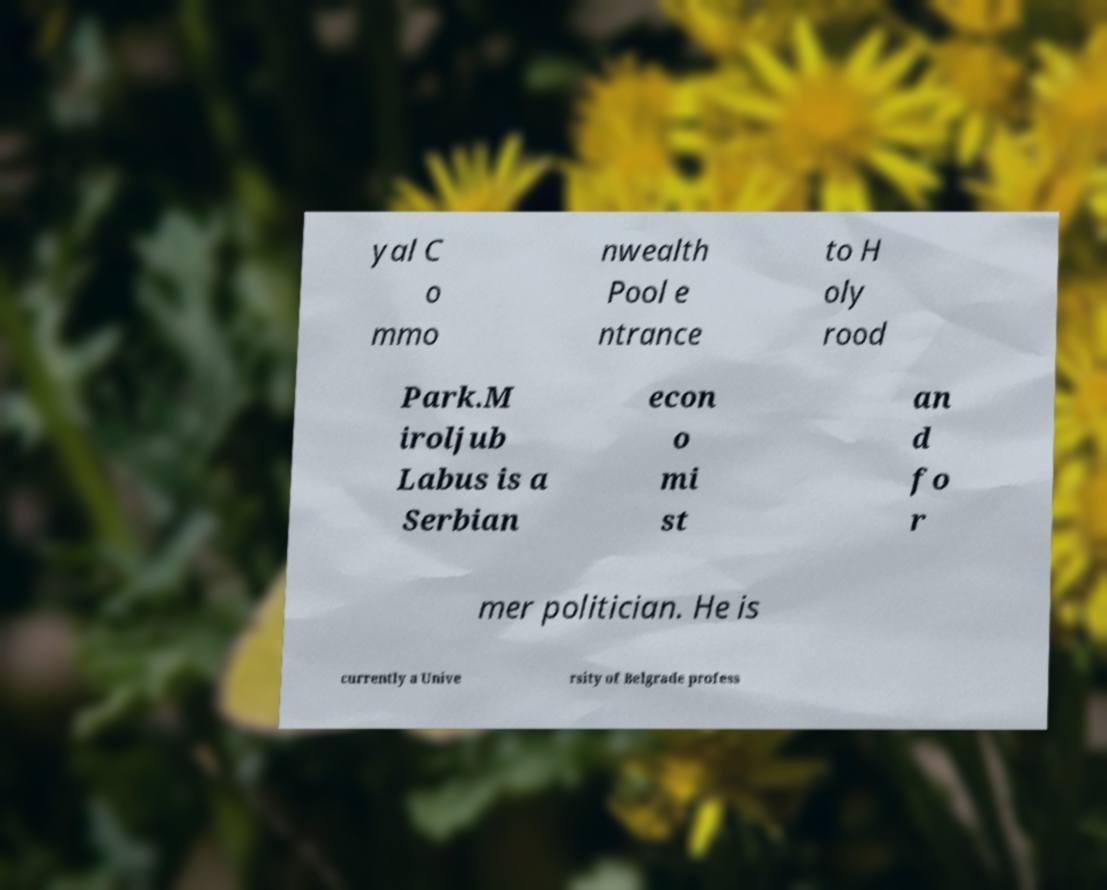I need the written content from this picture converted into text. Can you do that? yal C o mmo nwealth Pool e ntrance to H oly rood Park.M iroljub Labus is a Serbian econ o mi st an d fo r mer politician. He is currently a Unive rsity of Belgrade profess 